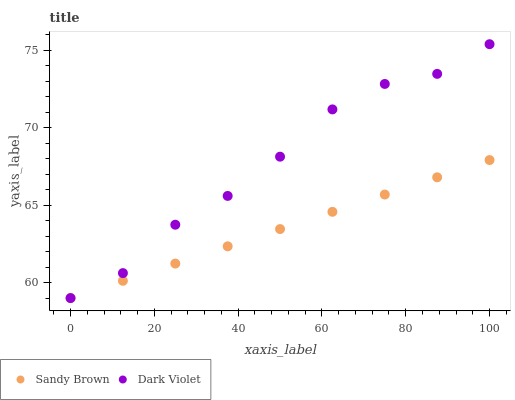Does Sandy Brown have the minimum area under the curve?
Answer yes or no. Yes. Does Dark Violet have the maximum area under the curve?
Answer yes or no. Yes. Does Dark Violet have the minimum area under the curve?
Answer yes or no. No. Is Sandy Brown the smoothest?
Answer yes or no. Yes. Is Dark Violet the roughest?
Answer yes or no. Yes. Is Dark Violet the smoothest?
Answer yes or no. No. Does Sandy Brown have the lowest value?
Answer yes or no. Yes. Does Dark Violet have the highest value?
Answer yes or no. Yes. Does Dark Violet intersect Sandy Brown?
Answer yes or no. Yes. Is Dark Violet less than Sandy Brown?
Answer yes or no. No. Is Dark Violet greater than Sandy Brown?
Answer yes or no. No. 